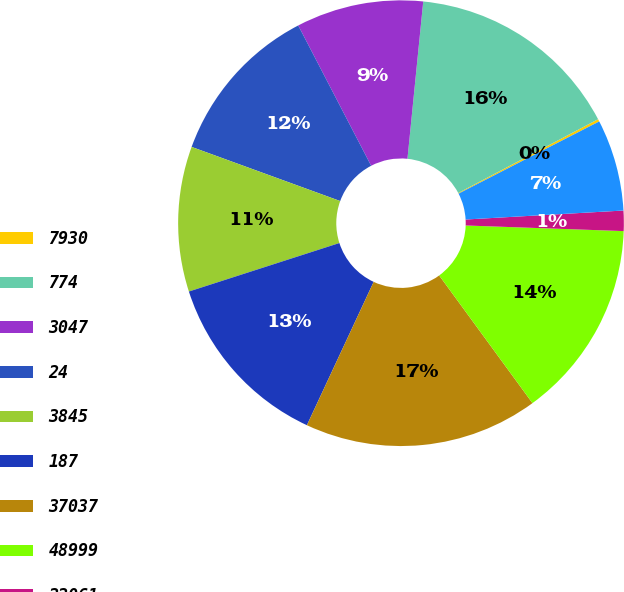Convert chart. <chart><loc_0><loc_0><loc_500><loc_500><pie_chart><fcel>7930<fcel>774<fcel>3047<fcel>24<fcel>3845<fcel>187<fcel>37037<fcel>48999<fcel>22061<fcel>3208<nl><fcel>0.18%<fcel>15.68%<fcel>9.22%<fcel>11.81%<fcel>10.52%<fcel>13.1%<fcel>16.98%<fcel>14.39%<fcel>1.47%<fcel>6.64%<nl></chart> 